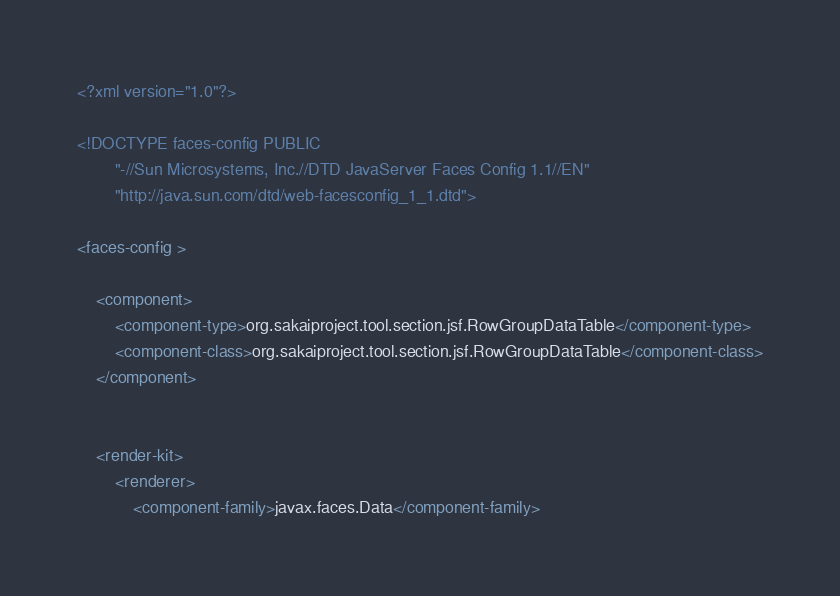Convert code to text. <code><loc_0><loc_0><loc_500><loc_500><_XML_><?xml version="1.0"?>

<!DOCTYPE faces-config PUBLIC
        "-//Sun Microsystems, Inc.//DTD JavaServer Faces Config 1.1//EN"
        "http://java.sun.com/dtd/web-facesconfig_1_1.dtd">

<faces-config >

    <component>
        <component-type>org.sakaiproject.tool.section.jsf.RowGroupDataTable</component-type>
        <component-class>org.sakaiproject.tool.section.jsf.RowGroupDataTable</component-class>
    </component>


    <render-kit>
        <renderer>
            <component-family>javax.faces.Data</component-family></code> 